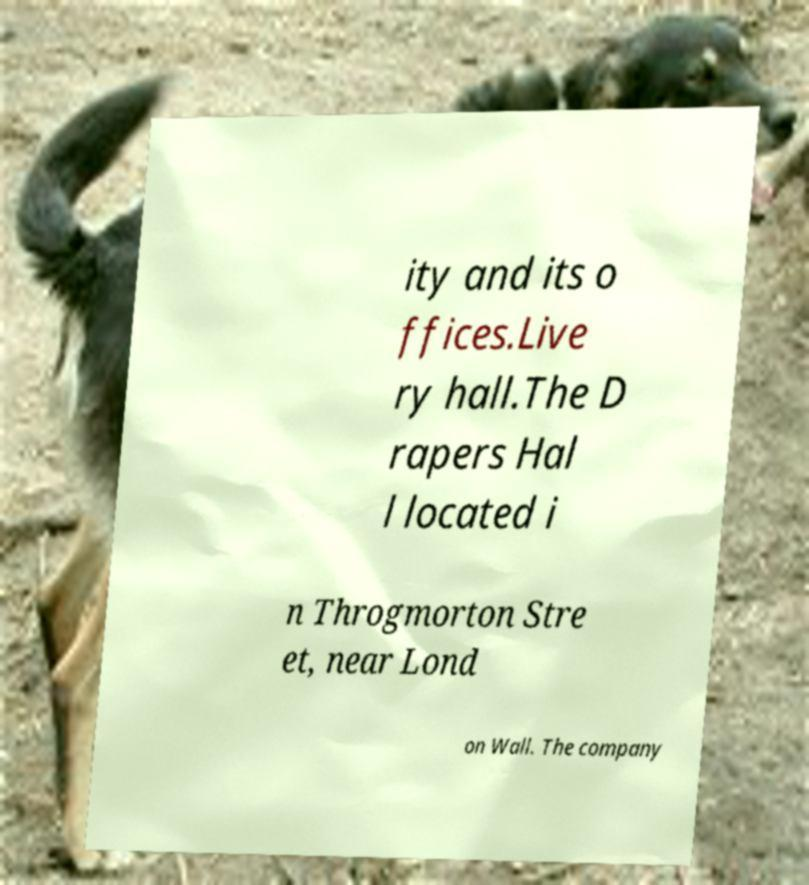What messages or text are displayed in this image? I need them in a readable, typed format. ity and its o ffices.Live ry hall.The D rapers Hal l located i n Throgmorton Stre et, near Lond on Wall. The company 